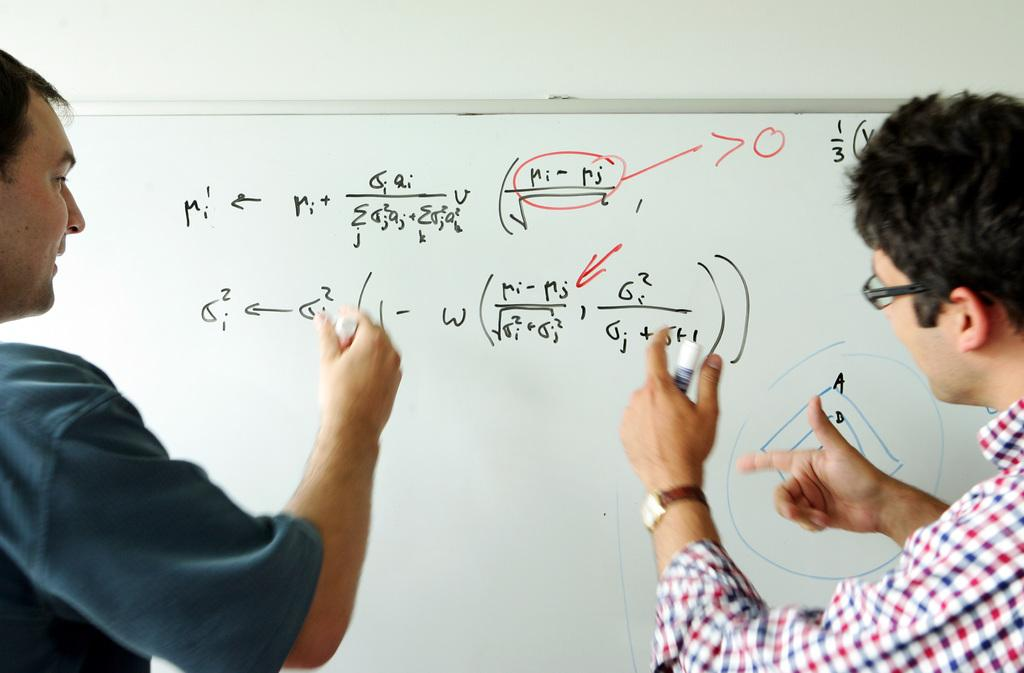<image>
Give a short and clear explanation of the subsequent image. Two people are writing on a whiteboard that has math equations that include the letters M and W. 